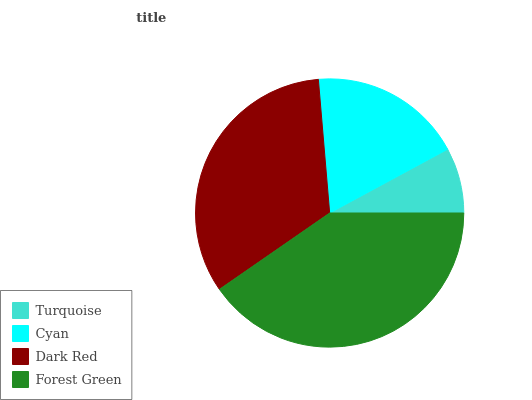Is Turquoise the minimum?
Answer yes or no. Yes. Is Forest Green the maximum?
Answer yes or no. Yes. Is Cyan the minimum?
Answer yes or no. No. Is Cyan the maximum?
Answer yes or no. No. Is Cyan greater than Turquoise?
Answer yes or no. Yes. Is Turquoise less than Cyan?
Answer yes or no. Yes. Is Turquoise greater than Cyan?
Answer yes or no. No. Is Cyan less than Turquoise?
Answer yes or no. No. Is Dark Red the high median?
Answer yes or no. Yes. Is Cyan the low median?
Answer yes or no. Yes. Is Turquoise the high median?
Answer yes or no. No. Is Turquoise the low median?
Answer yes or no. No. 